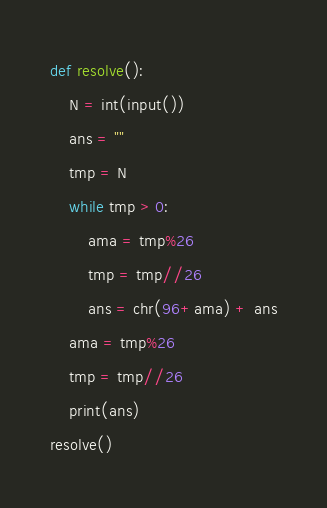Convert code to text. <code><loc_0><loc_0><loc_500><loc_500><_Python_>def resolve():
    N = int(input())
    ans = ""
    tmp = N
    while tmp > 0:
        ama = tmp%26
        tmp = tmp//26
        ans = chr(96+ama) + ans
    ama = tmp%26
    tmp = tmp//26
    print(ans)
resolve()</code> 